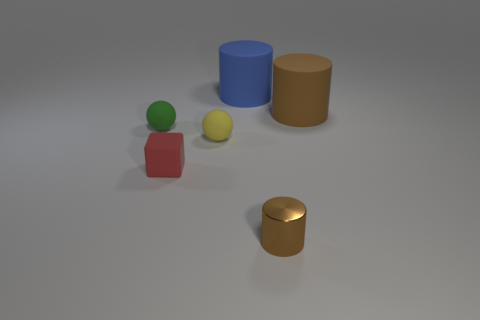The ball to the right of the cube in front of the small rubber ball to the left of the yellow ball is what color? The ball to the right of the cube, which is situated in front of the small rubber ball and to the left of the yellow ball, appears to be green in color. 